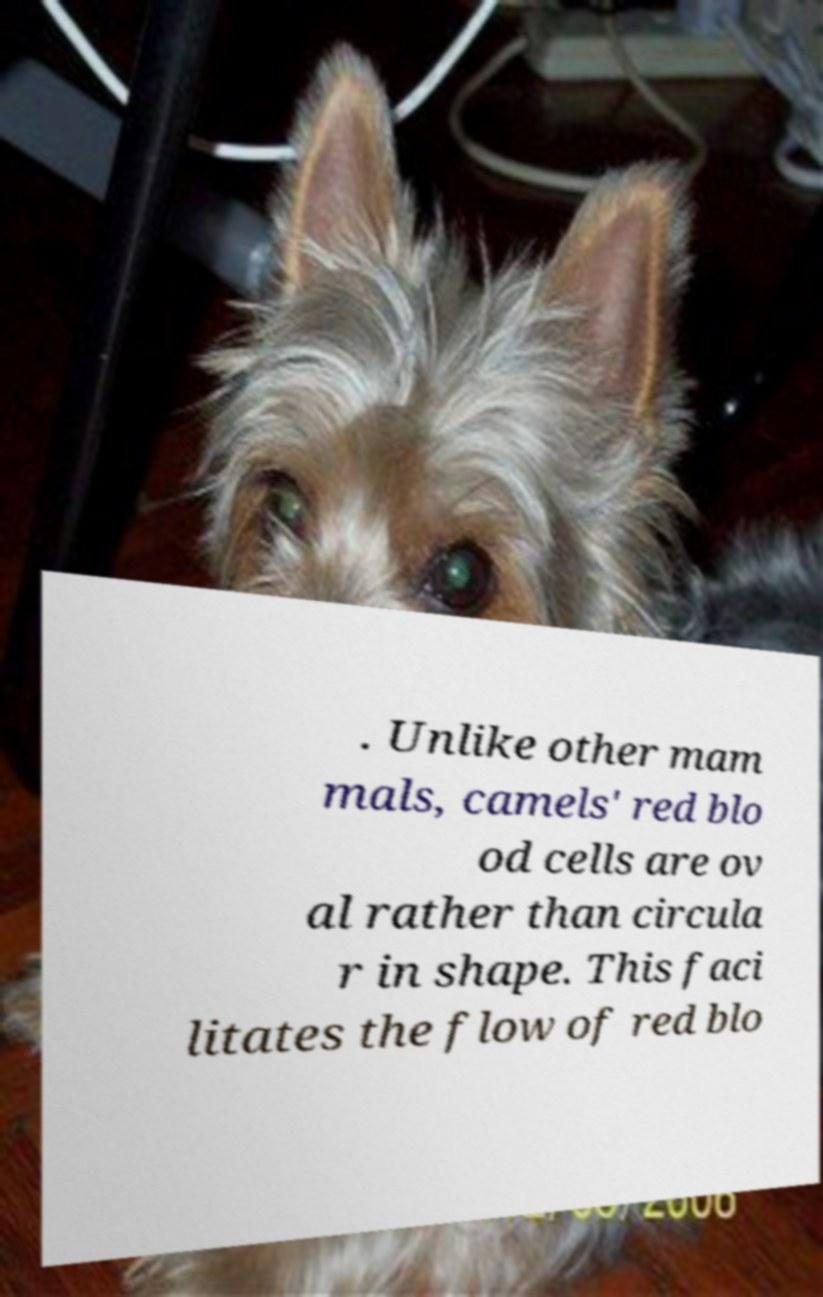Please identify and transcribe the text found in this image. . Unlike other mam mals, camels' red blo od cells are ov al rather than circula r in shape. This faci litates the flow of red blo 